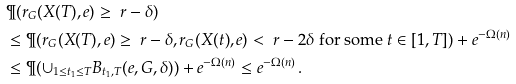<formula> <loc_0><loc_0><loc_500><loc_500>& \P ( r _ { G } ( X ( T ) , e ) \geq \ r - \delta ) \\ & \leq \P ( r _ { G } ( X ( T ) , e ) \geq \ r - \delta , r _ { G } ( X ( t ) , e ) < \ r - 2 \delta \text { for some } t \in [ 1 , T ] ) + e ^ { - \Omega ( n ) } \\ & \leq \P ( \cup _ { 1 \leq t _ { 1 } \leq T } B _ { t _ { 1 } , T } ( e , G , \delta ) ) + e ^ { - \Omega ( n ) } \leq e ^ { - \Omega ( n ) } \, .</formula> 